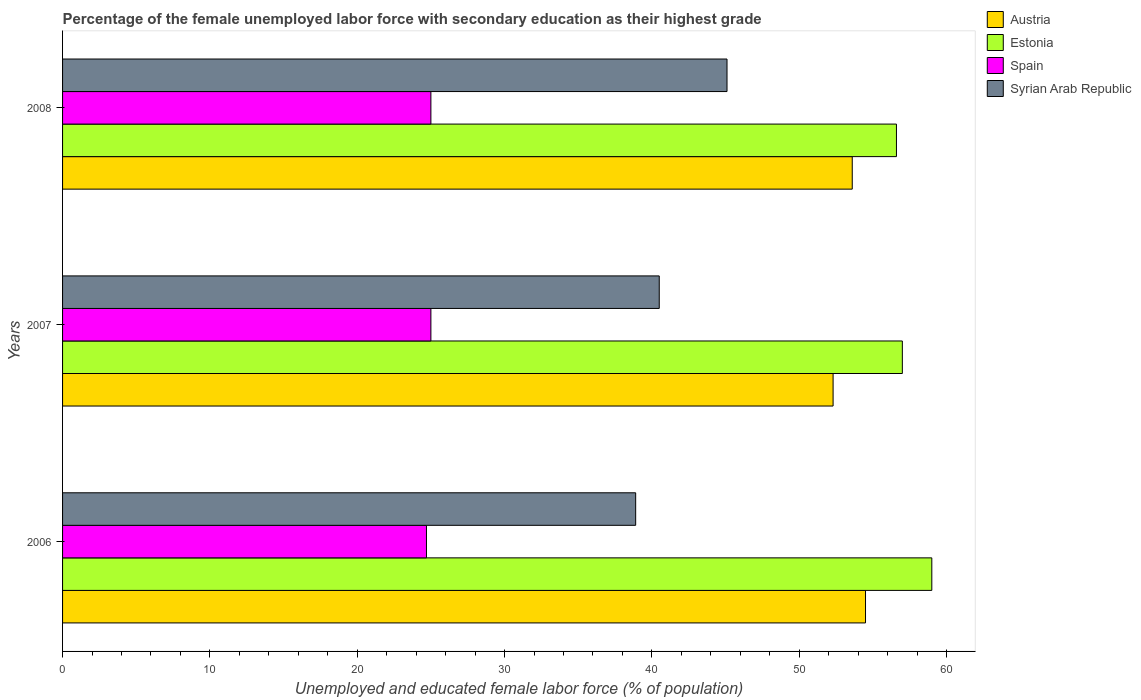How many bars are there on the 1st tick from the top?
Your answer should be compact. 4. In how many cases, is the number of bars for a given year not equal to the number of legend labels?
Ensure brevity in your answer.  0. What is the percentage of the unemployed female labor force with secondary education in Estonia in 2007?
Provide a short and direct response. 57. Across all years, what is the maximum percentage of the unemployed female labor force with secondary education in Estonia?
Give a very brief answer. 59. Across all years, what is the minimum percentage of the unemployed female labor force with secondary education in Estonia?
Offer a very short reply. 56.6. In which year was the percentage of the unemployed female labor force with secondary education in Syrian Arab Republic maximum?
Offer a terse response. 2008. What is the total percentage of the unemployed female labor force with secondary education in Syrian Arab Republic in the graph?
Give a very brief answer. 124.5. What is the difference between the percentage of the unemployed female labor force with secondary education in Syrian Arab Republic in 2007 and that in 2008?
Ensure brevity in your answer.  -4.6. What is the difference between the percentage of the unemployed female labor force with secondary education in Spain in 2006 and the percentage of the unemployed female labor force with secondary education in Austria in 2008?
Keep it short and to the point. -28.9. What is the average percentage of the unemployed female labor force with secondary education in Spain per year?
Provide a short and direct response. 24.9. In the year 2008, what is the difference between the percentage of the unemployed female labor force with secondary education in Estonia and percentage of the unemployed female labor force with secondary education in Syrian Arab Republic?
Make the answer very short. 11.5. In how many years, is the percentage of the unemployed female labor force with secondary education in Austria greater than 16 %?
Your response must be concise. 3. What is the ratio of the percentage of the unemployed female labor force with secondary education in Austria in 2006 to that in 2008?
Keep it short and to the point. 1.02. Is the difference between the percentage of the unemployed female labor force with secondary education in Estonia in 2007 and 2008 greater than the difference between the percentage of the unemployed female labor force with secondary education in Syrian Arab Republic in 2007 and 2008?
Offer a very short reply. Yes. What is the difference between the highest and the second highest percentage of the unemployed female labor force with secondary education in Spain?
Provide a short and direct response. 0. What is the difference between the highest and the lowest percentage of the unemployed female labor force with secondary education in Austria?
Offer a terse response. 2.2. In how many years, is the percentage of the unemployed female labor force with secondary education in Austria greater than the average percentage of the unemployed female labor force with secondary education in Austria taken over all years?
Ensure brevity in your answer.  2. Is the sum of the percentage of the unemployed female labor force with secondary education in Austria in 2006 and 2008 greater than the maximum percentage of the unemployed female labor force with secondary education in Syrian Arab Republic across all years?
Give a very brief answer. Yes. Is it the case that in every year, the sum of the percentage of the unemployed female labor force with secondary education in Spain and percentage of the unemployed female labor force with secondary education in Austria is greater than the sum of percentage of the unemployed female labor force with secondary education in Syrian Arab Republic and percentage of the unemployed female labor force with secondary education in Estonia?
Your response must be concise. No. What does the 3rd bar from the top in 2007 represents?
Give a very brief answer. Estonia. Is it the case that in every year, the sum of the percentage of the unemployed female labor force with secondary education in Syrian Arab Republic and percentage of the unemployed female labor force with secondary education in Austria is greater than the percentage of the unemployed female labor force with secondary education in Estonia?
Make the answer very short. Yes. How many bars are there?
Your answer should be compact. 12. How many years are there in the graph?
Make the answer very short. 3. What is the difference between two consecutive major ticks on the X-axis?
Offer a very short reply. 10. Are the values on the major ticks of X-axis written in scientific E-notation?
Offer a very short reply. No. Does the graph contain any zero values?
Your response must be concise. No. Where does the legend appear in the graph?
Ensure brevity in your answer.  Top right. How are the legend labels stacked?
Your answer should be very brief. Vertical. What is the title of the graph?
Your response must be concise. Percentage of the female unemployed labor force with secondary education as their highest grade. Does "Heavily indebted poor countries" appear as one of the legend labels in the graph?
Offer a very short reply. No. What is the label or title of the X-axis?
Ensure brevity in your answer.  Unemployed and educated female labor force (% of population). What is the label or title of the Y-axis?
Ensure brevity in your answer.  Years. What is the Unemployed and educated female labor force (% of population) in Austria in 2006?
Make the answer very short. 54.5. What is the Unemployed and educated female labor force (% of population) in Spain in 2006?
Your answer should be very brief. 24.7. What is the Unemployed and educated female labor force (% of population) of Syrian Arab Republic in 2006?
Offer a very short reply. 38.9. What is the Unemployed and educated female labor force (% of population) of Austria in 2007?
Offer a terse response. 52.3. What is the Unemployed and educated female labor force (% of population) of Estonia in 2007?
Your answer should be very brief. 57. What is the Unemployed and educated female labor force (% of population) of Spain in 2007?
Provide a succinct answer. 25. What is the Unemployed and educated female labor force (% of population) in Syrian Arab Republic in 2007?
Keep it short and to the point. 40.5. What is the Unemployed and educated female labor force (% of population) in Austria in 2008?
Make the answer very short. 53.6. What is the Unemployed and educated female labor force (% of population) of Estonia in 2008?
Offer a terse response. 56.6. What is the Unemployed and educated female labor force (% of population) in Spain in 2008?
Make the answer very short. 25. What is the Unemployed and educated female labor force (% of population) of Syrian Arab Republic in 2008?
Provide a short and direct response. 45.1. Across all years, what is the maximum Unemployed and educated female labor force (% of population) in Austria?
Ensure brevity in your answer.  54.5. Across all years, what is the maximum Unemployed and educated female labor force (% of population) of Estonia?
Ensure brevity in your answer.  59. Across all years, what is the maximum Unemployed and educated female labor force (% of population) in Spain?
Your response must be concise. 25. Across all years, what is the maximum Unemployed and educated female labor force (% of population) of Syrian Arab Republic?
Give a very brief answer. 45.1. Across all years, what is the minimum Unemployed and educated female labor force (% of population) of Austria?
Provide a short and direct response. 52.3. Across all years, what is the minimum Unemployed and educated female labor force (% of population) of Estonia?
Your answer should be compact. 56.6. Across all years, what is the minimum Unemployed and educated female labor force (% of population) of Spain?
Your response must be concise. 24.7. Across all years, what is the minimum Unemployed and educated female labor force (% of population) in Syrian Arab Republic?
Keep it short and to the point. 38.9. What is the total Unemployed and educated female labor force (% of population) of Austria in the graph?
Provide a succinct answer. 160.4. What is the total Unemployed and educated female labor force (% of population) of Estonia in the graph?
Give a very brief answer. 172.6. What is the total Unemployed and educated female labor force (% of population) of Spain in the graph?
Provide a short and direct response. 74.7. What is the total Unemployed and educated female labor force (% of population) of Syrian Arab Republic in the graph?
Your answer should be very brief. 124.5. What is the difference between the Unemployed and educated female labor force (% of population) in Austria in 2006 and that in 2007?
Your answer should be compact. 2.2. What is the difference between the Unemployed and educated female labor force (% of population) of Austria in 2006 and that in 2008?
Offer a very short reply. 0.9. What is the difference between the Unemployed and educated female labor force (% of population) of Estonia in 2006 and that in 2008?
Offer a very short reply. 2.4. What is the difference between the Unemployed and educated female labor force (% of population) of Estonia in 2007 and that in 2008?
Provide a short and direct response. 0.4. What is the difference between the Unemployed and educated female labor force (% of population) in Spain in 2007 and that in 2008?
Offer a terse response. 0. What is the difference between the Unemployed and educated female labor force (% of population) of Syrian Arab Republic in 2007 and that in 2008?
Ensure brevity in your answer.  -4.6. What is the difference between the Unemployed and educated female labor force (% of population) in Austria in 2006 and the Unemployed and educated female labor force (% of population) in Estonia in 2007?
Your answer should be very brief. -2.5. What is the difference between the Unemployed and educated female labor force (% of population) in Austria in 2006 and the Unemployed and educated female labor force (% of population) in Spain in 2007?
Your response must be concise. 29.5. What is the difference between the Unemployed and educated female labor force (% of population) in Estonia in 2006 and the Unemployed and educated female labor force (% of population) in Syrian Arab Republic in 2007?
Make the answer very short. 18.5. What is the difference between the Unemployed and educated female labor force (% of population) in Spain in 2006 and the Unemployed and educated female labor force (% of population) in Syrian Arab Republic in 2007?
Your response must be concise. -15.8. What is the difference between the Unemployed and educated female labor force (% of population) of Austria in 2006 and the Unemployed and educated female labor force (% of population) of Spain in 2008?
Your answer should be compact. 29.5. What is the difference between the Unemployed and educated female labor force (% of population) of Estonia in 2006 and the Unemployed and educated female labor force (% of population) of Spain in 2008?
Offer a very short reply. 34. What is the difference between the Unemployed and educated female labor force (% of population) of Estonia in 2006 and the Unemployed and educated female labor force (% of population) of Syrian Arab Republic in 2008?
Provide a succinct answer. 13.9. What is the difference between the Unemployed and educated female labor force (% of population) in Spain in 2006 and the Unemployed and educated female labor force (% of population) in Syrian Arab Republic in 2008?
Your response must be concise. -20.4. What is the difference between the Unemployed and educated female labor force (% of population) in Austria in 2007 and the Unemployed and educated female labor force (% of population) in Spain in 2008?
Keep it short and to the point. 27.3. What is the difference between the Unemployed and educated female labor force (% of population) of Austria in 2007 and the Unemployed and educated female labor force (% of population) of Syrian Arab Republic in 2008?
Offer a terse response. 7.2. What is the difference between the Unemployed and educated female labor force (% of population) in Estonia in 2007 and the Unemployed and educated female labor force (% of population) in Spain in 2008?
Give a very brief answer. 32. What is the difference between the Unemployed and educated female labor force (% of population) of Spain in 2007 and the Unemployed and educated female labor force (% of population) of Syrian Arab Republic in 2008?
Offer a very short reply. -20.1. What is the average Unemployed and educated female labor force (% of population) in Austria per year?
Your answer should be compact. 53.47. What is the average Unemployed and educated female labor force (% of population) in Estonia per year?
Keep it short and to the point. 57.53. What is the average Unemployed and educated female labor force (% of population) in Spain per year?
Provide a short and direct response. 24.9. What is the average Unemployed and educated female labor force (% of population) of Syrian Arab Republic per year?
Keep it short and to the point. 41.5. In the year 2006, what is the difference between the Unemployed and educated female labor force (% of population) of Austria and Unemployed and educated female labor force (% of population) of Spain?
Give a very brief answer. 29.8. In the year 2006, what is the difference between the Unemployed and educated female labor force (% of population) in Estonia and Unemployed and educated female labor force (% of population) in Spain?
Offer a very short reply. 34.3. In the year 2006, what is the difference between the Unemployed and educated female labor force (% of population) of Estonia and Unemployed and educated female labor force (% of population) of Syrian Arab Republic?
Ensure brevity in your answer.  20.1. In the year 2006, what is the difference between the Unemployed and educated female labor force (% of population) in Spain and Unemployed and educated female labor force (% of population) in Syrian Arab Republic?
Your answer should be very brief. -14.2. In the year 2007, what is the difference between the Unemployed and educated female labor force (% of population) in Austria and Unemployed and educated female labor force (% of population) in Spain?
Offer a terse response. 27.3. In the year 2007, what is the difference between the Unemployed and educated female labor force (% of population) in Austria and Unemployed and educated female labor force (% of population) in Syrian Arab Republic?
Offer a terse response. 11.8. In the year 2007, what is the difference between the Unemployed and educated female labor force (% of population) in Spain and Unemployed and educated female labor force (% of population) in Syrian Arab Republic?
Provide a succinct answer. -15.5. In the year 2008, what is the difference between the Unemployed and educated female labor force (% of population) of Austria and Unemployed and educated female labor force (% of population) of Estonia?
Offer a very short reply. -3. In the year 2008, what is the difference between the Unemployed and educated female labor force (% of population) of Austria and Unemployed and educated female labor force (% of population) of Spain?
Offer a terse response. 28.6. In the year 2008, what is the difference between the Unemployed and educated female labor force (% of population) of Estonia and Unemployed and educated female labor force (% of population) of Spain?
Make the answer very short. 31.6. In the year 2008, what is the difference between the Unemployed and educated female labor force (% of population) in Estonia and Unemployed and educated female labor force (% of population) in Syrian Arab Republic?
Keep it short and to the point. 11.5. In the year 2008, what is the difference between the Unemployed and educated female labor force (% of population) in Spain and Unemployed and educated female labor force (% of population) in Syrian Arab Republic?
Give a very brief answer. -20.1. What is the ratio of the Unemployed and educated female labor force (% of population) in Austria in 2006 to that in 2007?
Your answer should be very brief. 1.04. What is the ratio of the Unemployed and educated female labor force (% of population) of Estonia in 2006 to that in 2007?
Provide a short and direct response. 1.04. What is the ratio of the Unemployed and educated female labor force (% of population) of Spain in 2006 to that in 2007?
Your answer should be very brief. 0.99. What is the ratio of the Unemployed and educated female labor force (% of population) in Syrian Arab Republic in 2006 to that in 2007?
Give a very brief answer. 0.96. What is the ratio of the Unemployed and educated female labor force (% of population) in Austria in 2006 to that in 2008?
Keep it short and to the point. 1.02. What is the ratio of the Unemployed and educated female labor force (% of population) in Estonia in 2006 to that in 2008?
Provide a succinct answer. 1.04. What is the ratio of the Unemployed and educated female labor force (% of population) in Spain in 2006 to that in 2008?
Offer a very short reply. 0.99. What is the ratio of the Unemployed and educated female labor force (% of population) in Syrian Arab Republic in 2006 to that in 2008?
Offer a terse response. 0.86. What is the ratio of the Unemployed and educated female labor force (% of population) of Austria in 2007 to that in 2008?
Keep it short and to the point. 0.98. What is the ratio of the Unemployed and educated female labor force (% of population) of Estonia in 2007 to that in 2008?
Your answer should be compact. 1.01. What is the ratio of the Unemployed and educated female labor force (% of population) in Spain in 2007 to that in 2008?
Your answer should be compact. 1. What is the ratio of the Unemployed and educated female labor force (% of population) in Syrian Arab Republic in 2007 to that in 2008?
Offer a terse response. 0.9. What is the difference between the highest and the second highest Unemployed and educated female labor force (% of population) of Estonia?
Offer a terse response. 2. What is the difference between the highest and the second highest Unemployed and educated female labor force (% of population) of Spain?
Your response must be concise. 0. What is the difference between the highest and the lowest Unemployed and educated female labor force (% of population) of Austria?
Your answer should be compact. 2.2. What is the difference between the highest and the lowest Unemployed and educated female labor force (% of population) of Estonia?
Ensure brevity in your answer.  2.4. 